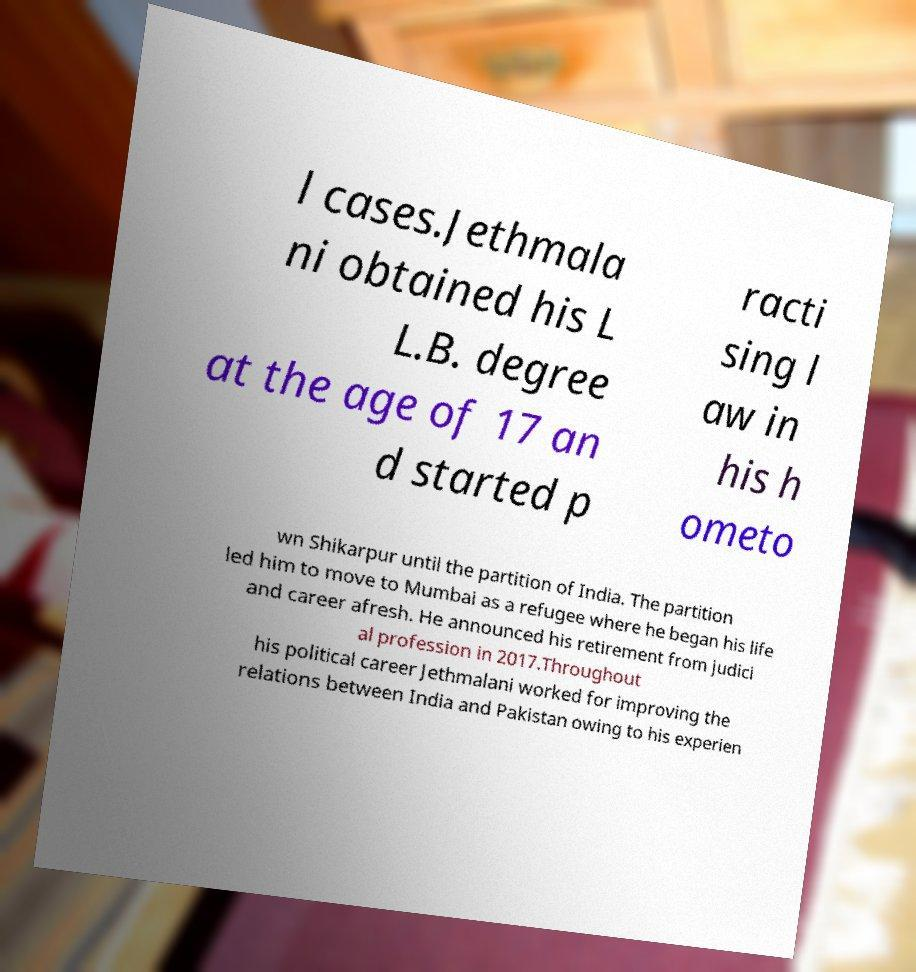Can you accurately transcribe the text from the provided image for me? l cases.Jethmala ni obtained his L L.B. degree at the age of 17 an d started p racti sing l aw in his h ometo wn Shikarpur until the partition of India. The partition led him to move to Mumbai as a refugee where he began his life and career afresh. He announced his retirement from judici al profession in 2017.Throughout his political career Jethmalani worked for improving the relations between India and Pakistan owing to his experien 